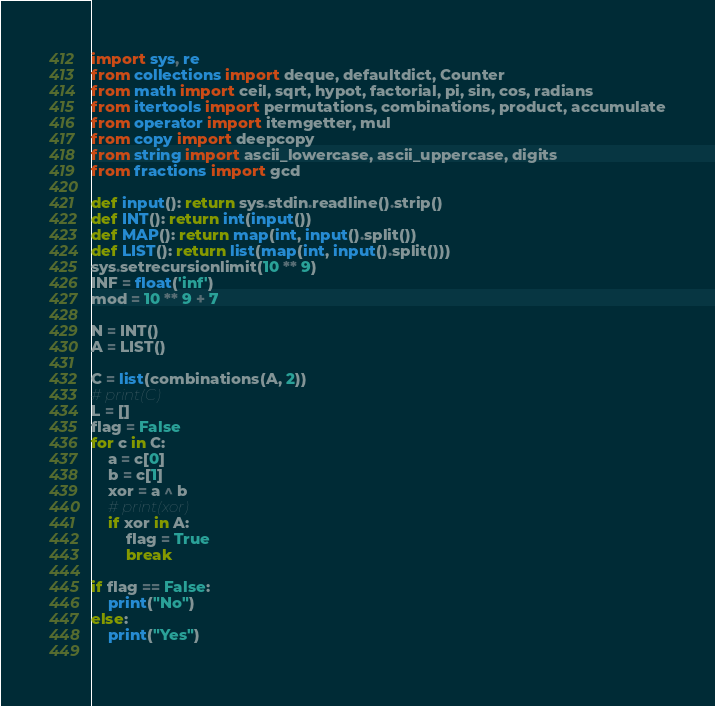<code> <loc_0><loc_0><loc_500><loc_500><_Python_>import sys, re
from collections import deque, defaultdict, Counter
from math import ceil, sqrt, hypot, factorial, pi, sin, cos, radians
from itertools import permutations, combinations, product, accumulate
from operator import itemgetter, mul
from copy import deepcopy
from string import ascii_lowercase, ascii_uppercase, digits
from fractions import gcd
 
def input(): return sys.stdin.readline().strip()
def INT(): return int(input())
def MAP(): return map(int, input().split())
def LIST(): return list(map(int, input().split()))
sys.setrecursionlimit(10 ** 9)
INF = float('inf')
mod = 10 ** 9 + 7

N = INT()
A = LIST()

C = list(combinations(A, 2))
# print(C)
L = []
flag = False
for c in C:
    a = c[0]
    b = c[1]
    xor = a ^ b
    # print(xor)
    if xor in A:
        flag = True
        break
        
if flag == False:
    print("No")
else:
    print("Yes")    
    




</code> 